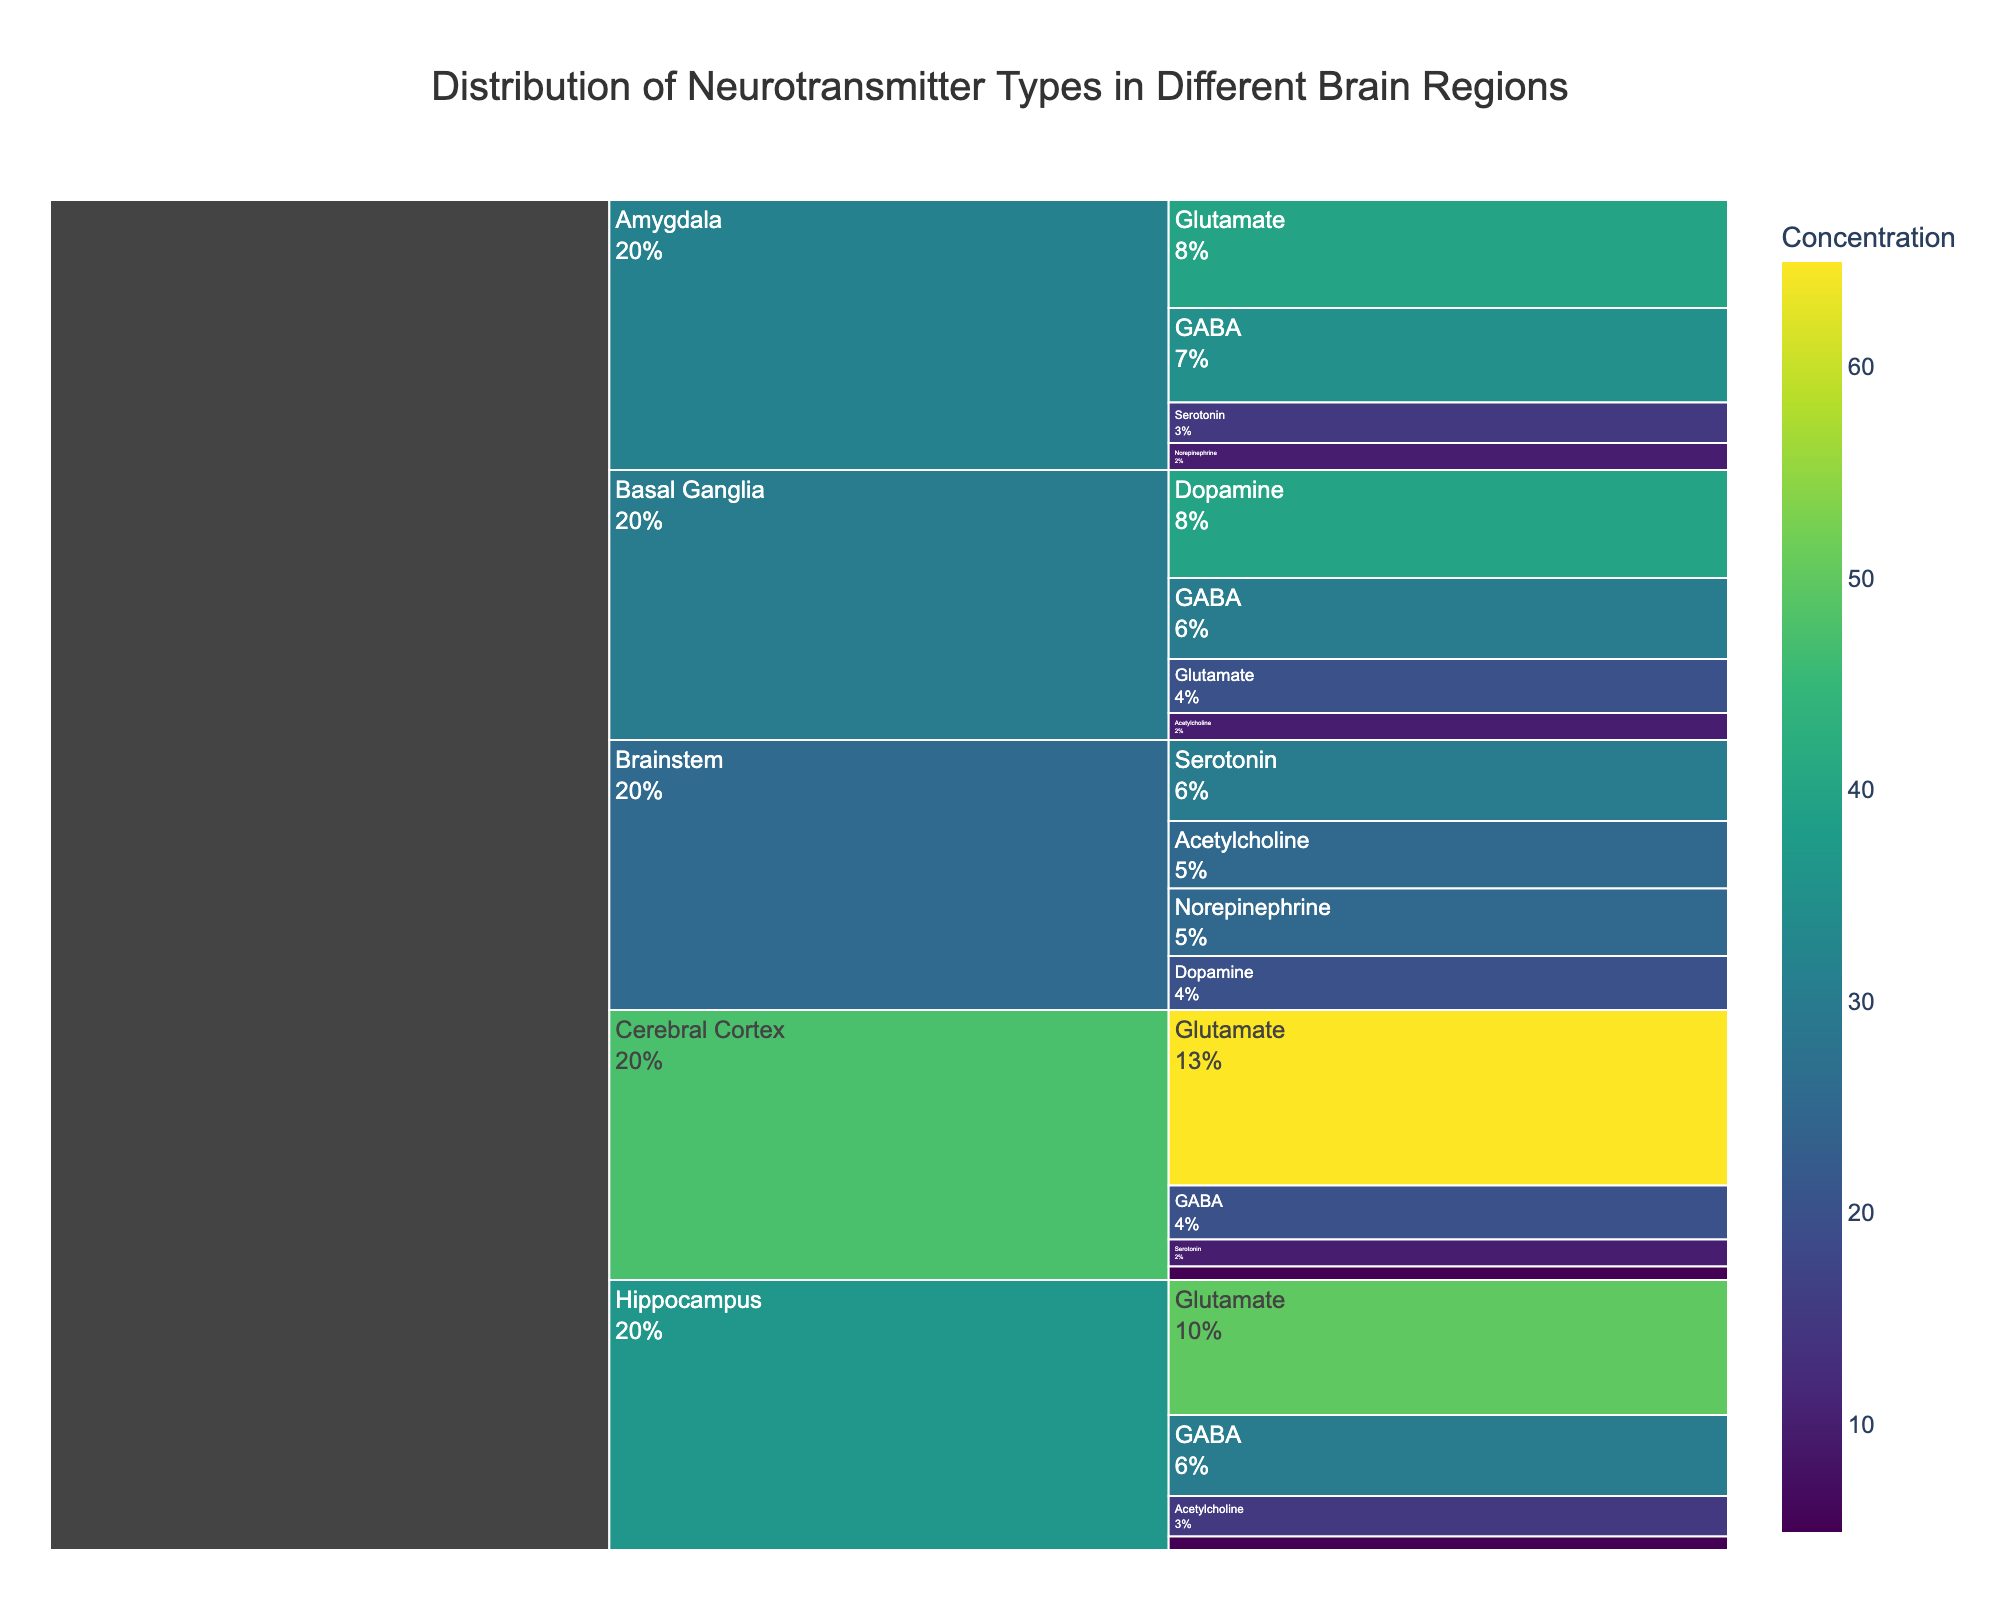What is the title of the chart? The title is typically located at the top center of the chart in a larger font. Reading the title helps to understand what the chart represents.
Answer: Distribution of Neurotransmitter Types in Different Brain Regions Which neurotransmitter has the highest concentration in the Cerebral Cortex? In the Icicle Chart, follow the path leading from 'Cerebral Cortex' to each neurotransmitter and observe the concentration values. The neurotransmitter with the largest value is the answer.
Answer: Glutamate What is the combined concentration of GABA across all brain regions? Locate the segments corresponding to 'GABA' in each brain region and sum the concentration values: 20 (Cerebral Cortex) + 30 (Basal Ganglia) + 30 (Hippocampus) + 35 (Amygdala) = 115.
Answer: 115 How does the concentration of Dopamine in the Basal Ganglia compare to that in the Cerebral Cortex? Find the 'Basal Ganglia' segment and 'Dopamine' under it (40), then compare it to the 'Cerebral Cortex' segment and 'Dopamine' under it (5). Basal Ganglia has a higher concentration.
Answer: Basal Ganglia has a higher concentration Which brain region has the highest concentration of Serotonin? Follow the paths for 'Serotonin' under each brain region and compare their values. The Brainstem has the highest value of 30.
Answer: Brainstem What are the total concentrations of neurotransmitters in the Amygdala? Sum the concentrations of all neurotransmitters under Amygdala: 40 (Glutamate) + 35 (GABA) + 15 (Serotonin) + 10 (Norepinephrine) = 100.
Answer: 100 Which two brain regions have equal concentrations of Acetylcholine? Compare the concentration values of Acetylcholine across all regions and identify the ones with matching values: Basal Ganglia (10) and Hippocampus (15).
Answer: None What is the percentage of GABA in the Hippocampus relative to its total concentration of neurotransmitters? Compute the percentage as (Concentration of GABA in Hippocampus / Total concentration in Hippocampus) * 100. Using values: (30 / 100) * 100 = 30%.
Answer: 30% Is Norepinephrine present in the Cerebral Cortex? Look for 'Norepinephrine' under the 'Cerebral Cortex' segment of the chart. Finding it indicates its presence.
Answer: No 